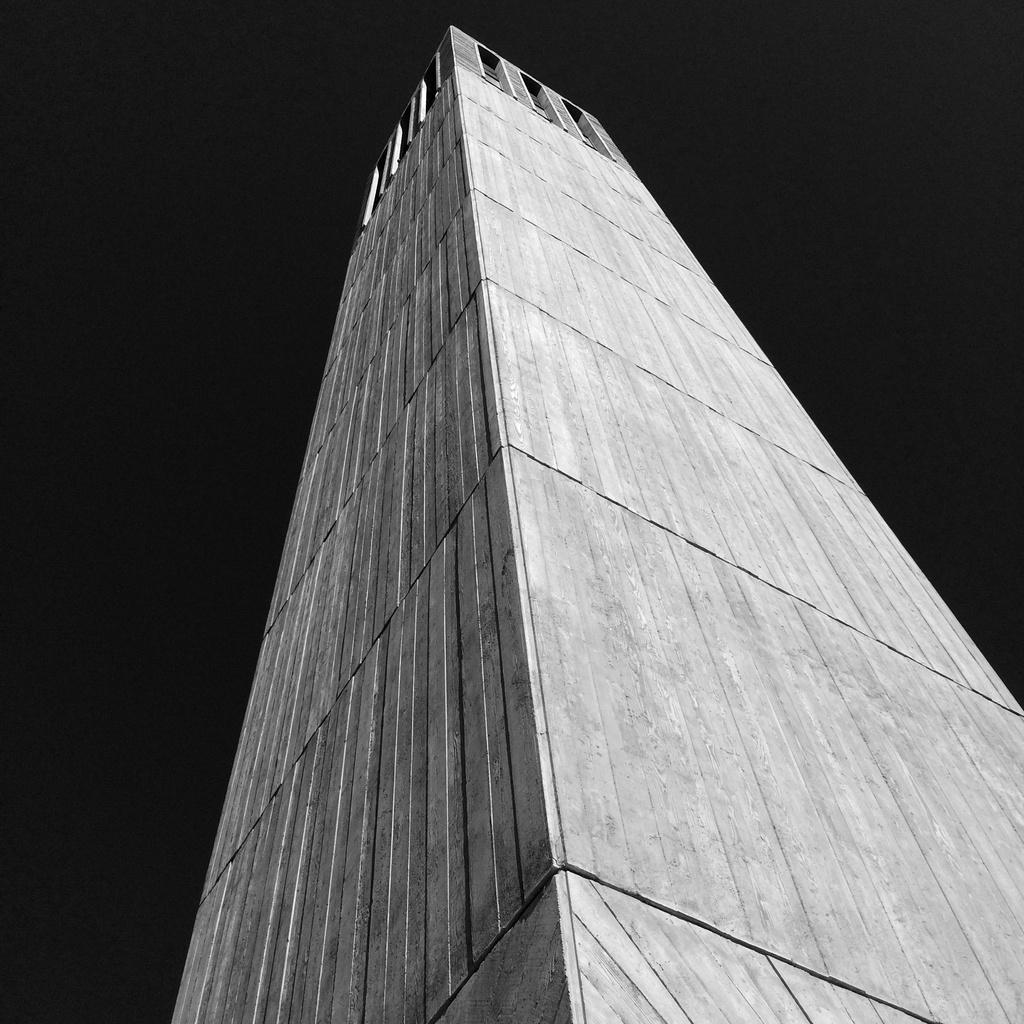What type of building is in the image? There is a skyscraper in the image. Can you describe the lighting conditions on the left side of the image? There is darkness on the left side of the image. What type of adjustment is the wren making to the band in the image? There is no wren or band present in the image. 